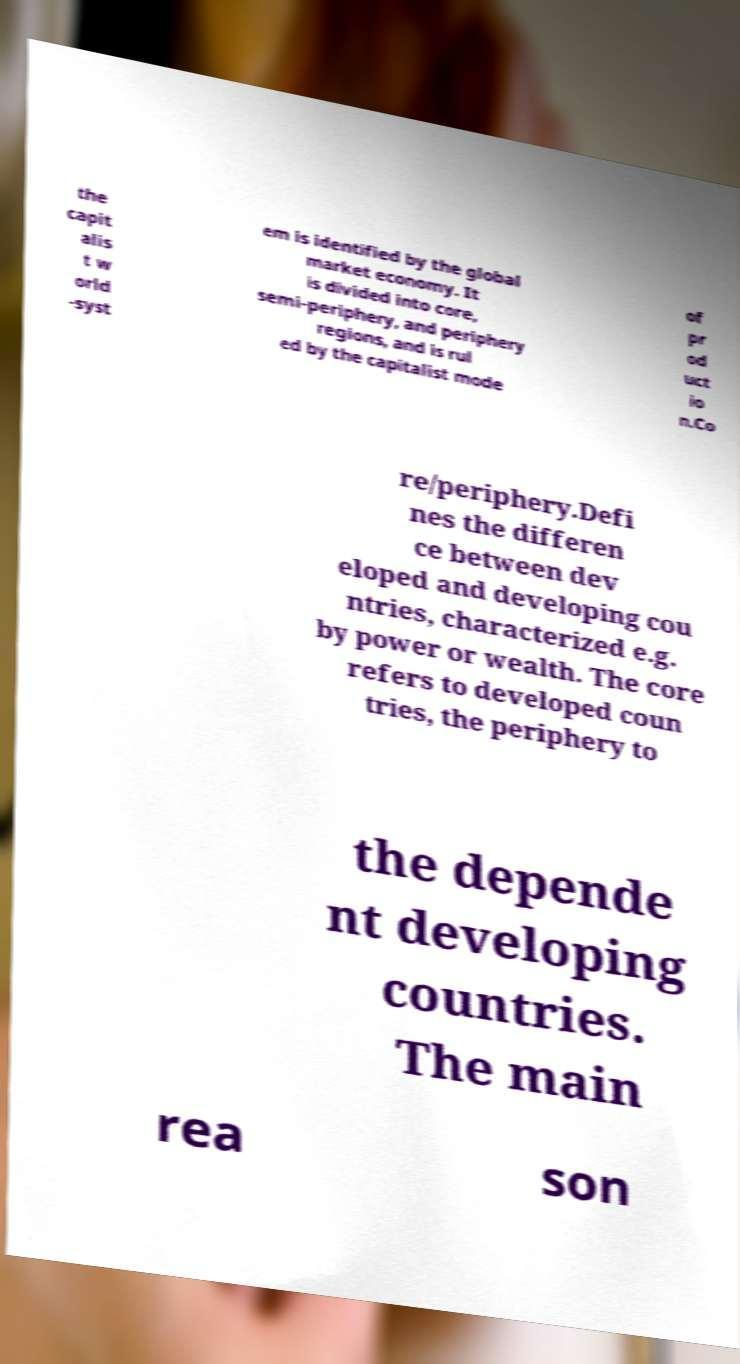Please identify and transcribe the text found in this image. the capit alis t w orld -syst em is identified by the global market economy. It is divided into core, semi-periphery, and periphery regions, and is rul ed by the capitalist mode of pr od uct io n.Co re/periphery.Defi nes the differen ce between dev eloped and developing cou ntries, characterized e.g. by power or wealth. The core refers to developed coun tries, the periphery to the depende nt developing countries. The main rea son 